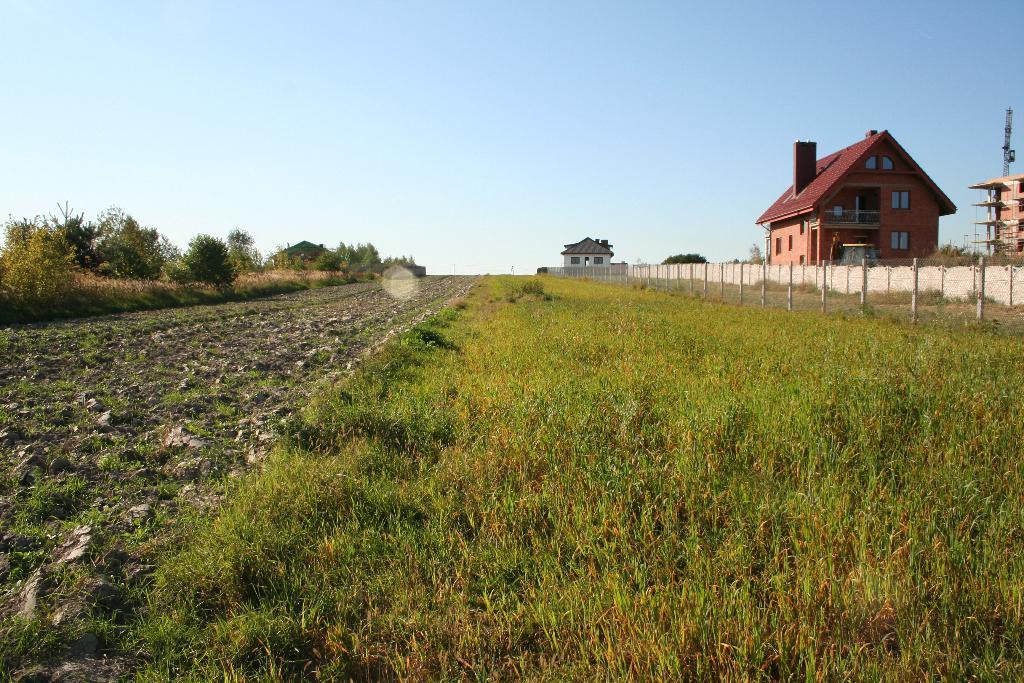Please provide a concise description of this image. At the bottom of the image there is grass. On the right we can see a fence and buildings. On the left there are trees. At the top there is sky. 